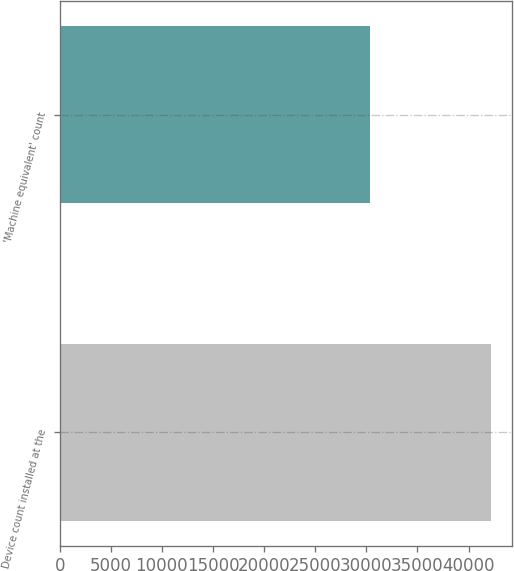Convert chart to OTSL. <chart><loc_0><loc_0><loc_500><loc_500><bar_chart><fcel>Device count installed at the<fcel>'Machine equivalent' count<nl><fcel>42153<fcel>30326<nl></chart> 